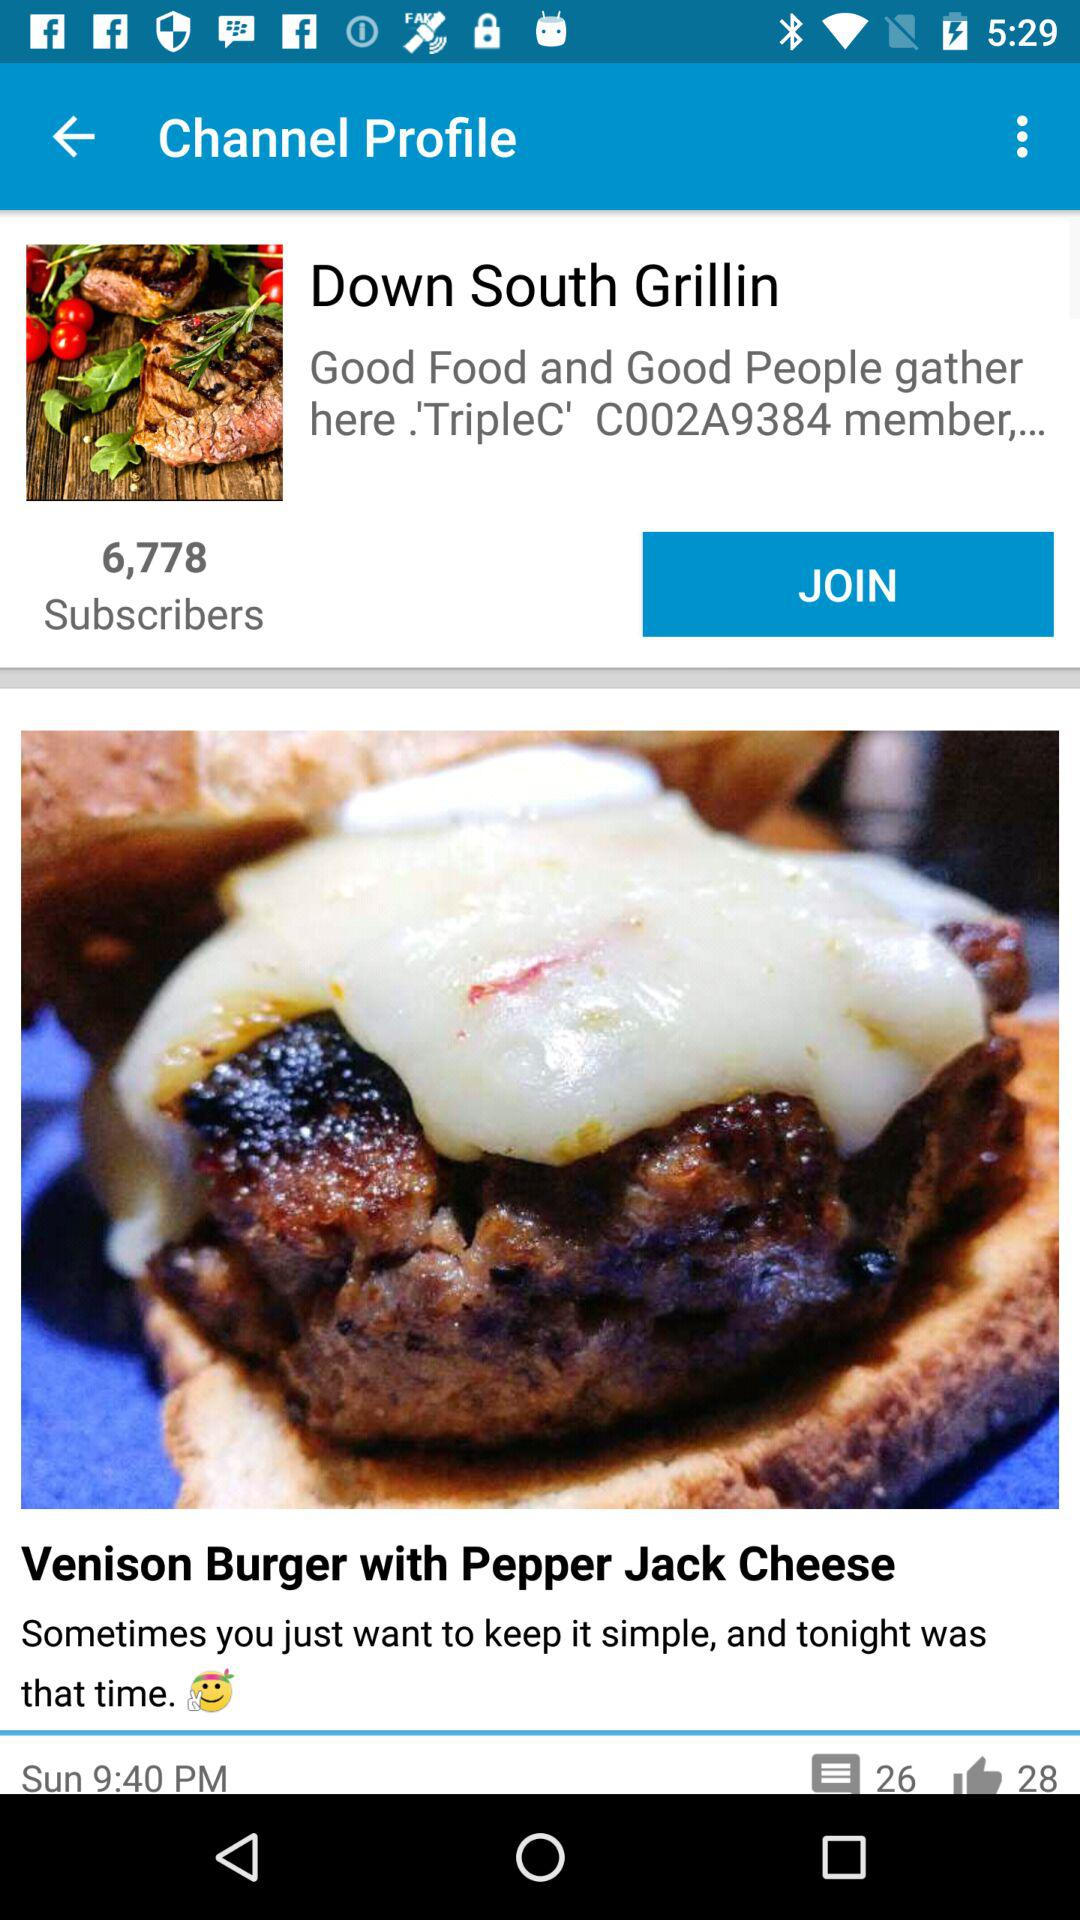What is the number of likes on the venison burger with pepper jack cheese? The number of likes on the venison burger with pepper jack cheese is 28. 